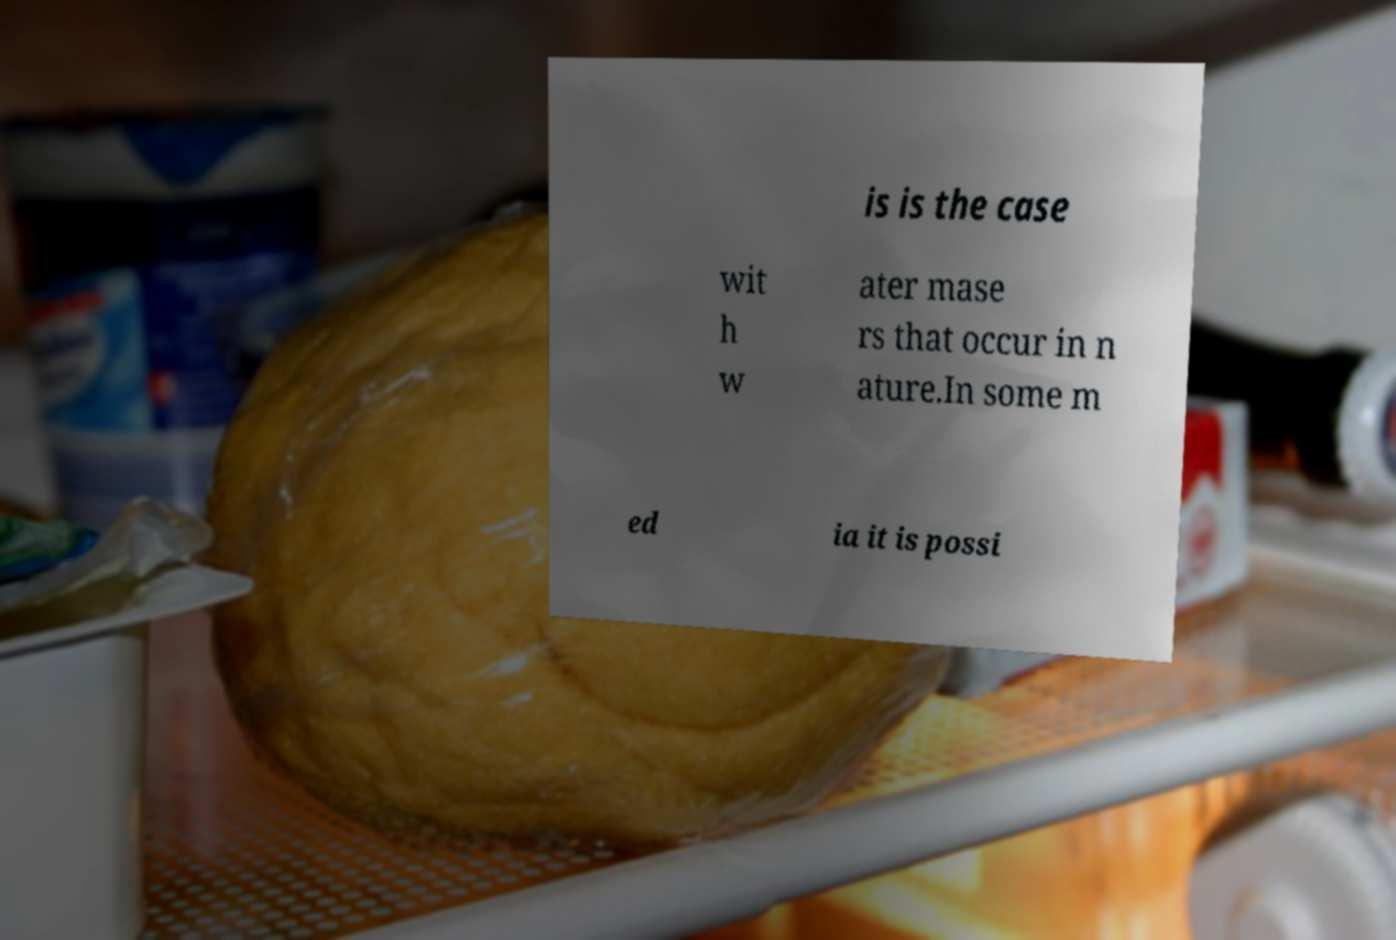Please read and relay the text visible in this image. What does it say? is is the case wit h w ater mase rs that occur in n ature.In some m ed ia it is possi 